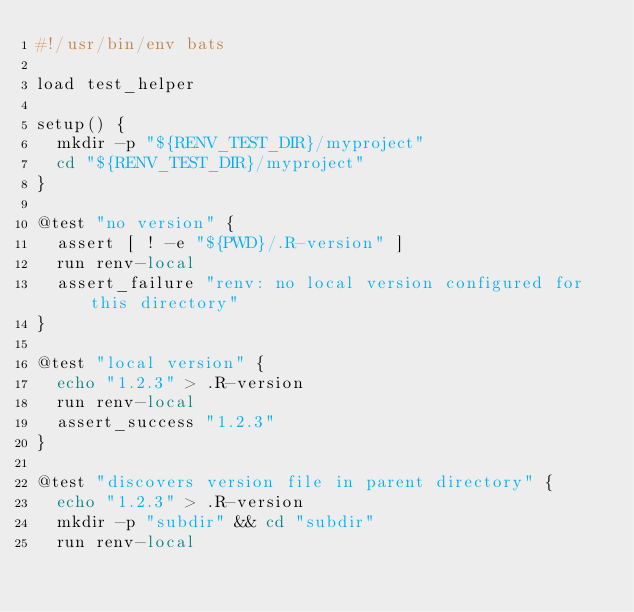Convert code to text. <code><loc_0><loc_0><loc_500><loc_500><_Bash_>#!/usr/bin/env bats

load test_helper

setup() {
  mkdir -p "${RENV_TEST_DIR}/myproject"
  cd "${RENV_TEST_DIR}/myproject"
}

@test "no version" {
  assert [ ! -e "${PWD}/.R-version" ]
  run renv-local
  assert_failure "renv: no local version configured for this directory"
}

@test "local version" {
  echo "1.2.3" > .R-version
  run renv-local
  assert_success "1.2.3"
}

@test "discovers version file in parent directory" {
  echo "1.2.3" > .R-version
  mkdir -p "subdir" && cd "subdir"
  run renv-local</code> 